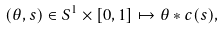<formula> <loc_0><loc_0><loc_500><loc_500>( \theta , s ) \in S ^ { 1 } \times [ 0 , 1 ] \mapsto \theta * c ( s ) ,</formula> 